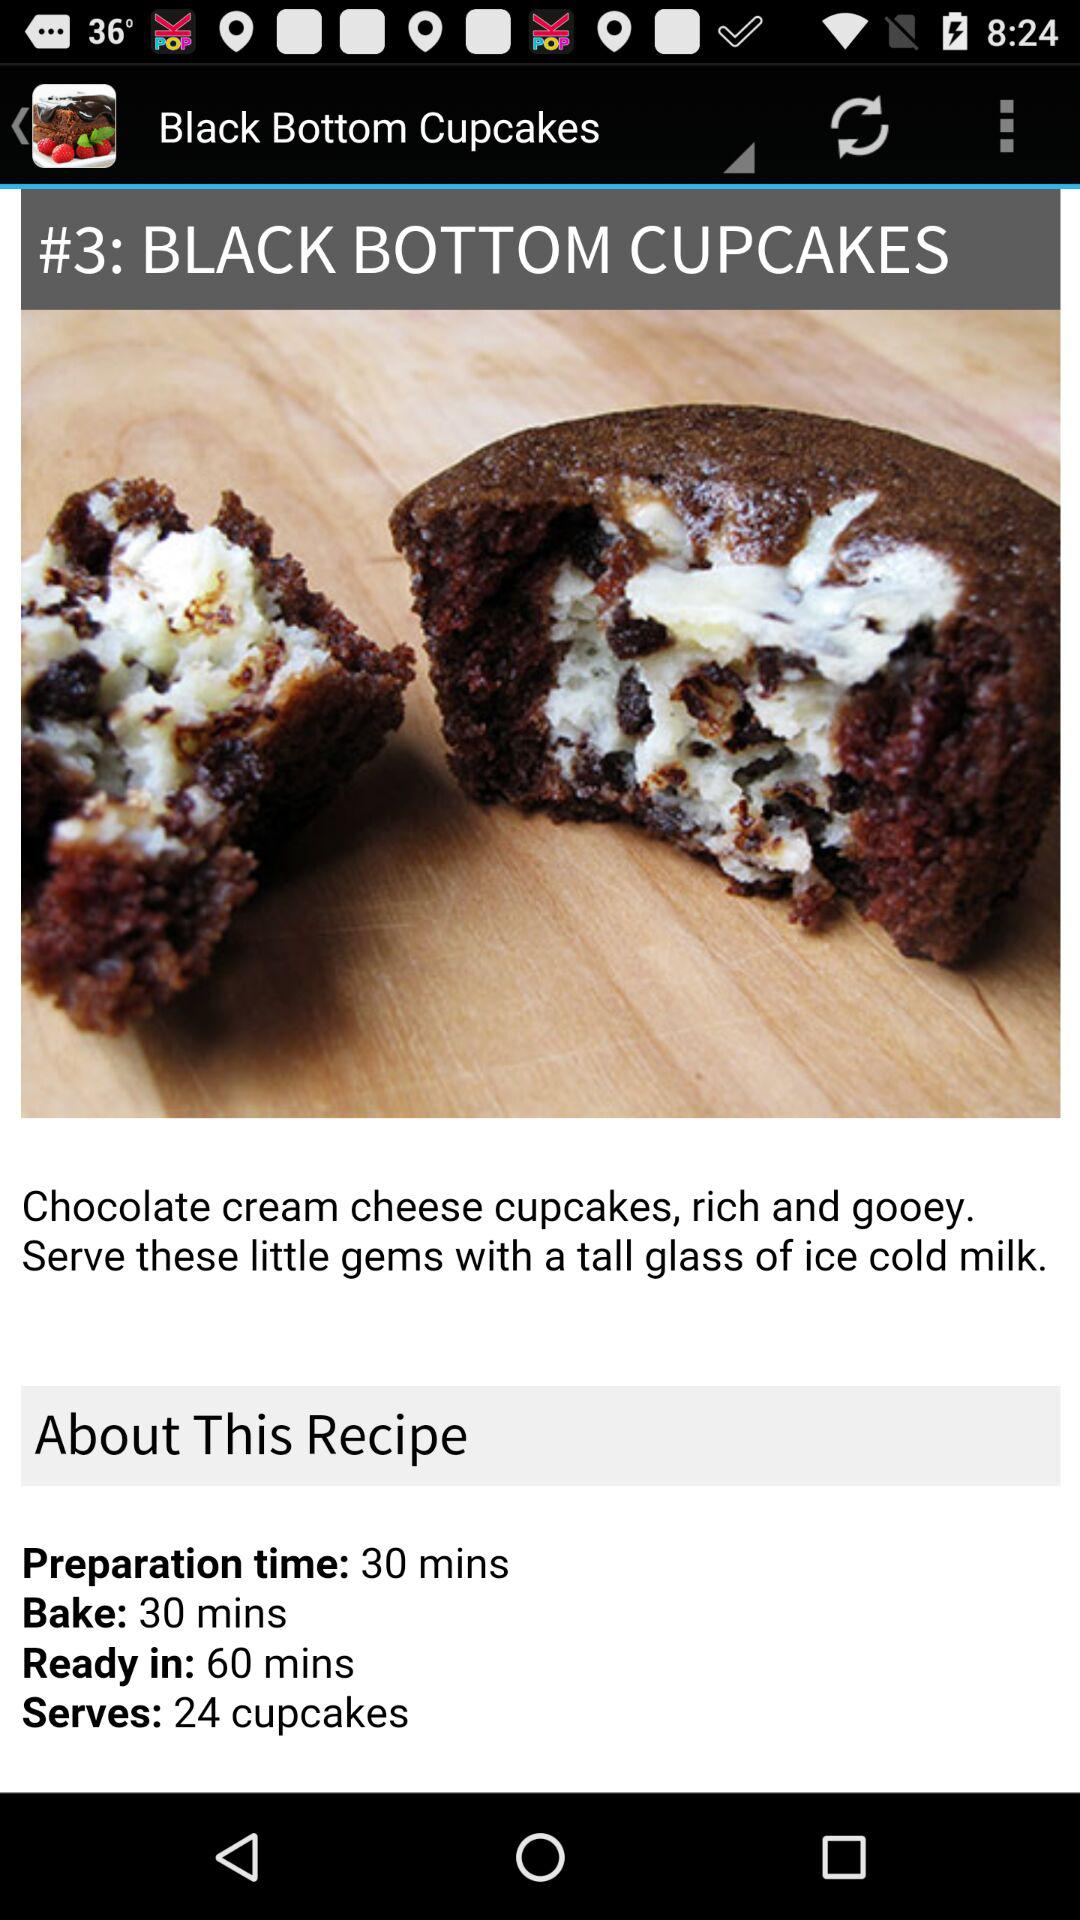What's the total preparation time? The total preparation time is 30 minutes. 